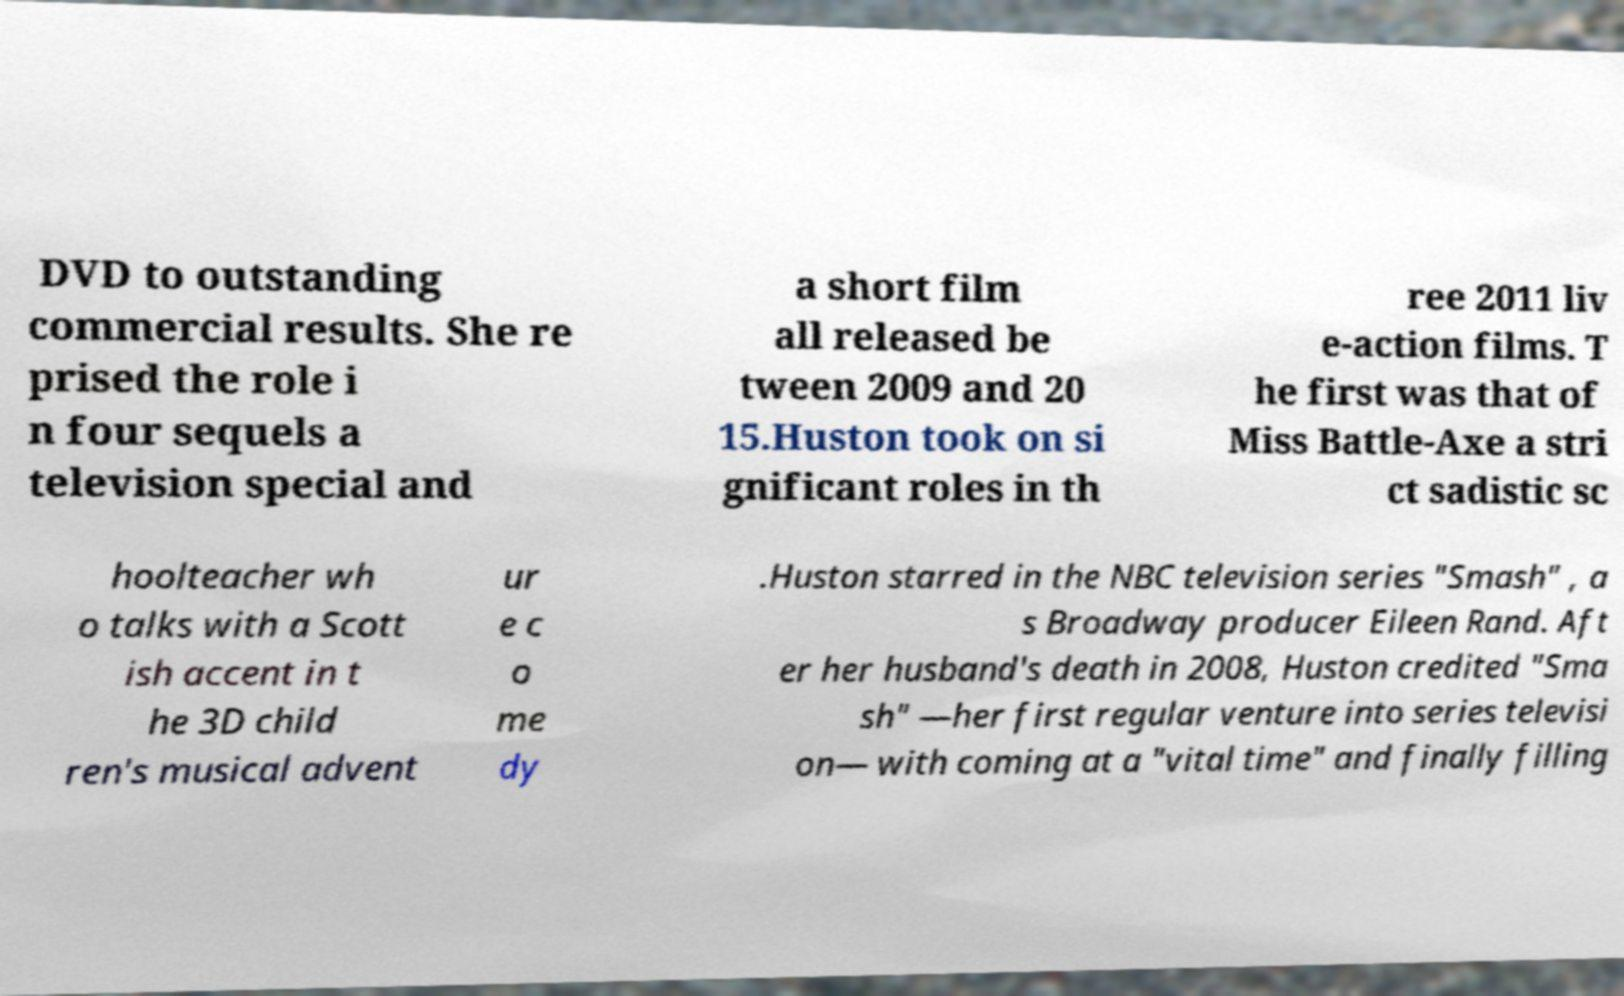Can you read and provide the text displayed in the image?This photo seems to have some interesting text. Can you extract and type it out for me? DVD to outstanding commercial results. She re prised the role i n four sequels a television special and a short film all released be tween 2009 and 20 15.Huston took on si gnificant roles in th ree 2011 liv e-action films. T he first was that of Miss Battle-Axe a stri ct sadistic sc hoolteacher wh o talks with a Scott ish accent in t he 3D child ren's musical advent ur e c o me dy .Huston starred in the NBC television series "Smash" , a s Broadway producer Eileen Rand. Aft er her husband's death in 2008, Huston credited "Sma sh" —her first regular venture into series televisi on— with coming at a "vital time" and finally filling 